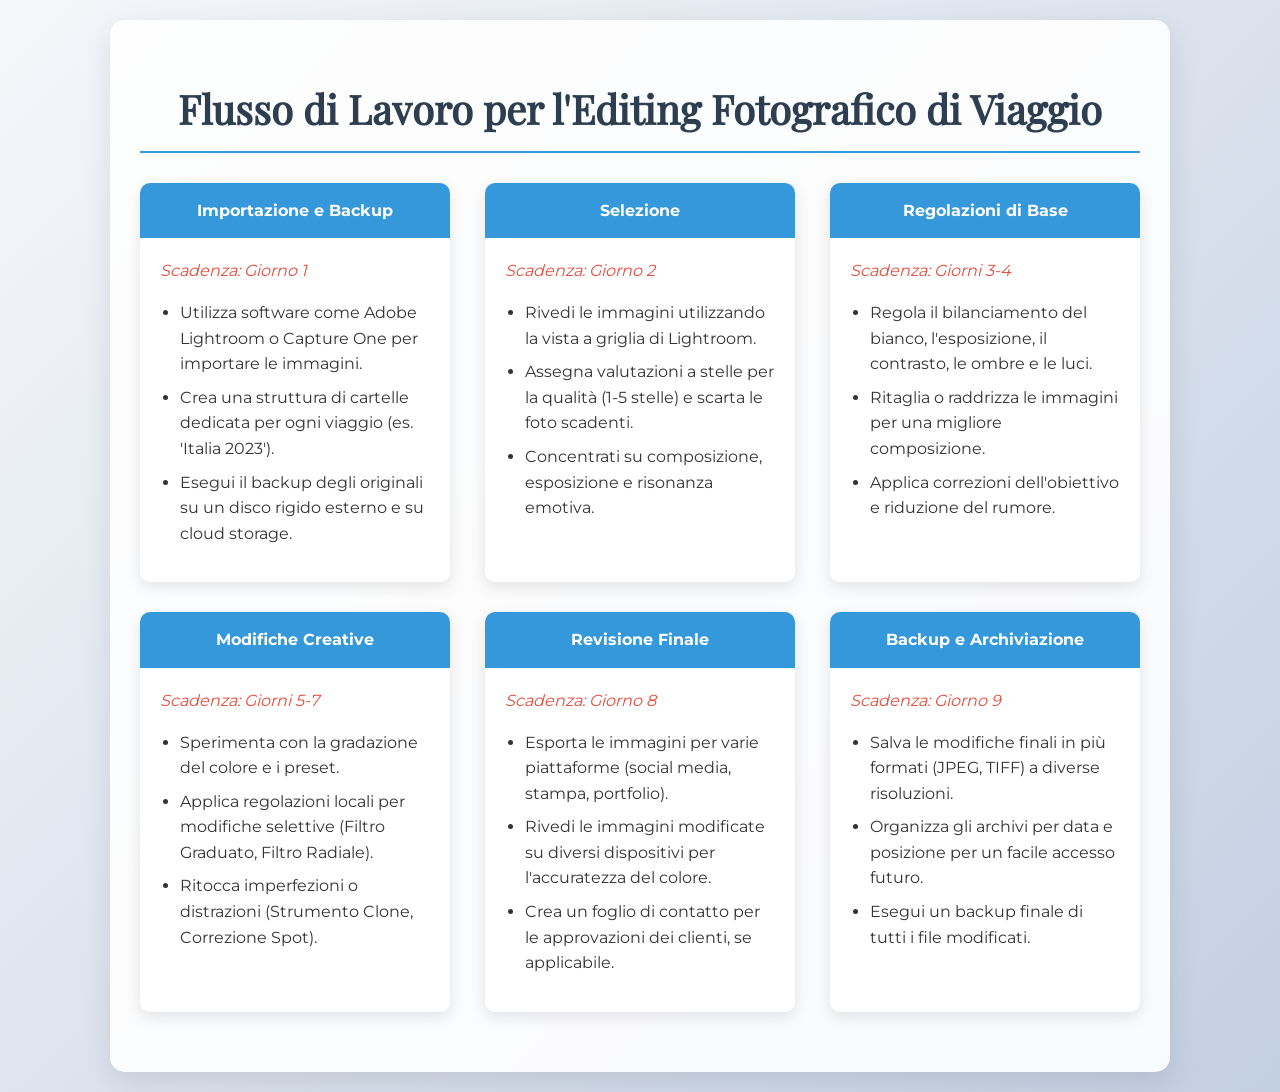Qual è la scadenza per la fase di Importazione e Backup? La scadenza per la fase di Importazione e Backup è specificata nel documento.
Answer: Giorno 1 Quali software possono essere utilizzati per l'importazione delle immagini? Il documento menziona specificamente i software consigliati per l'importazione delle immagini.
Answer: Adobe Lightroom o Capture One Quanti giorni sono riservati per le Modifiche Creative? Il numero di giorni indicati per le Modifiche Creative è descritto nel documento.
Answer: Giorni 5-7 Qual è il primo passo nel flusso di lavoro? Il primo passo nel flusso di lavoro è indicato nel documento.
Answer: Importazione e Backup Cosa deve essere fatto nel giorno 8? Il documento specifica le attività che devono essere completate nel giorno 8.
Answer: Revisione Finale Quale tecnica è suggerita per le regolazioni locali? La tecnica proposta per le regolazioni locali è menzionata nel documento.
Answer: Filtro Graduato, Filtro Radiale Che tipo di immagini deve essere esportato nella Revisione Finale? Il documento chiarisce il tipo di immagini esportate durante la Revisione Finale.
Answer: Immagini modificate Qual è la scadenza per la fase di Backup e Archiviazione? La scadenza per la fase di Backup e Archiviazione è indicata nel documento.
Answer: Giorno 9 